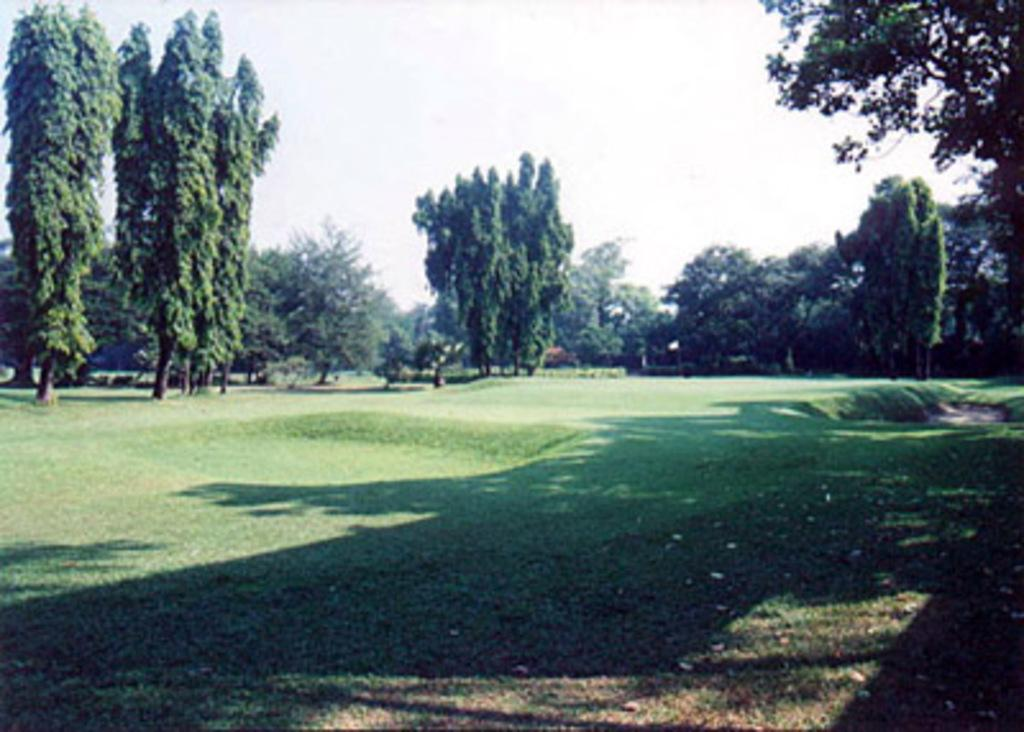What type of terrain is visible at the bottom of the image? There is grass on the ground at the bottom of the image. What can be seen in the distance in the image? There are trees in the background of the image. What else is visible in the background besides trees? There are some objects visible in the background. What is visible above the trees and objects in the image? The sky is visible in the background of the image. Can you describe the experience of the rat in the image? There is no rat present in the image, so it is not possible to describe any experience related to a rat. 